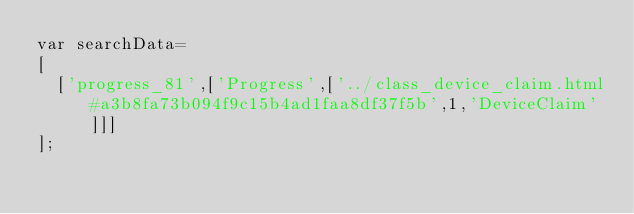<code> <loc_0><loc_0><loc_500><loc_500><_JavaScript_>var searchData=
[
  ['progress_81',['Progress',['../class_device_claim.html#a3b8fa73b094f9c15b4ad1faa8df37f5b',1,'DeviceClaim']]]
];
</code> 